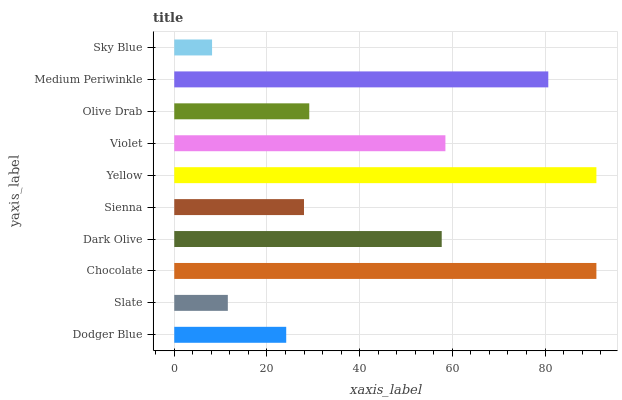Is Sky Blue the minimum?
Answer yes or no. Yes. Is Chocolate the maximum?
Answer yes or no. Yes. Is Slate the minimum?
Answer yes or no. No. Is Slate the maximum?
Answer yes or no. No. Is Dodger Blue greater than Slate?
Answer yes or no. Yes. Is Slate less than Dodger Blue?
Answer yes or no. Yes. Is Slate greater than Dodger Blue?
Answer yes or no. No. Is Dodger Blue less than Slate?
Answer yes or no. No. Is Dark Olive the high median?
Answer yes or no. Yes. Is Olive Drab the low median?
Answer yes or no. Yes. Is Sienna the high median?
Answer yes or no. No. Is Sienna the low median?
Answer yes or no. No. 